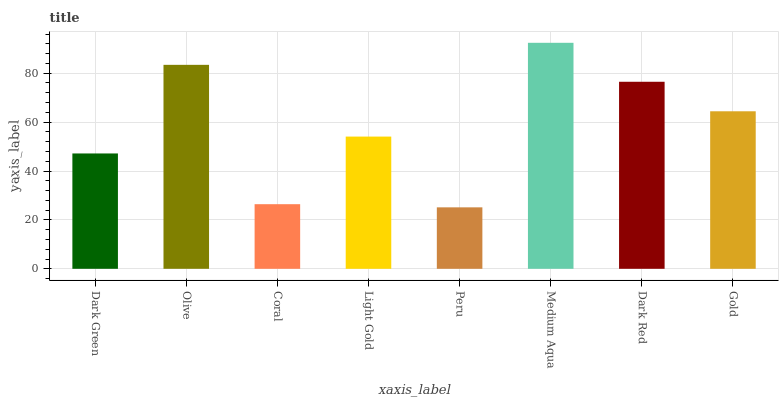Is Olive the minimum?
Answer yes or no. No. Is Olive the maximum?
Answer yes or no. No. Is Olive greater than Dark Green?
Answer yes or no. Yes. Is Dark Green less than Olive?
Answer yes or no. Yes. Is Dark Green greater than Olive?
Answer yes or no. No. Is Olive less than Dark Green?
Answer yes or no. No. Is Gold the high median?
Answer yes or no. Yes. Is Light Gold the low median?
Answer yes or no. Yes. Is Peru the high median?
Answer yes or no. No. Is Peru the low median?
Answer yes or no. No. 